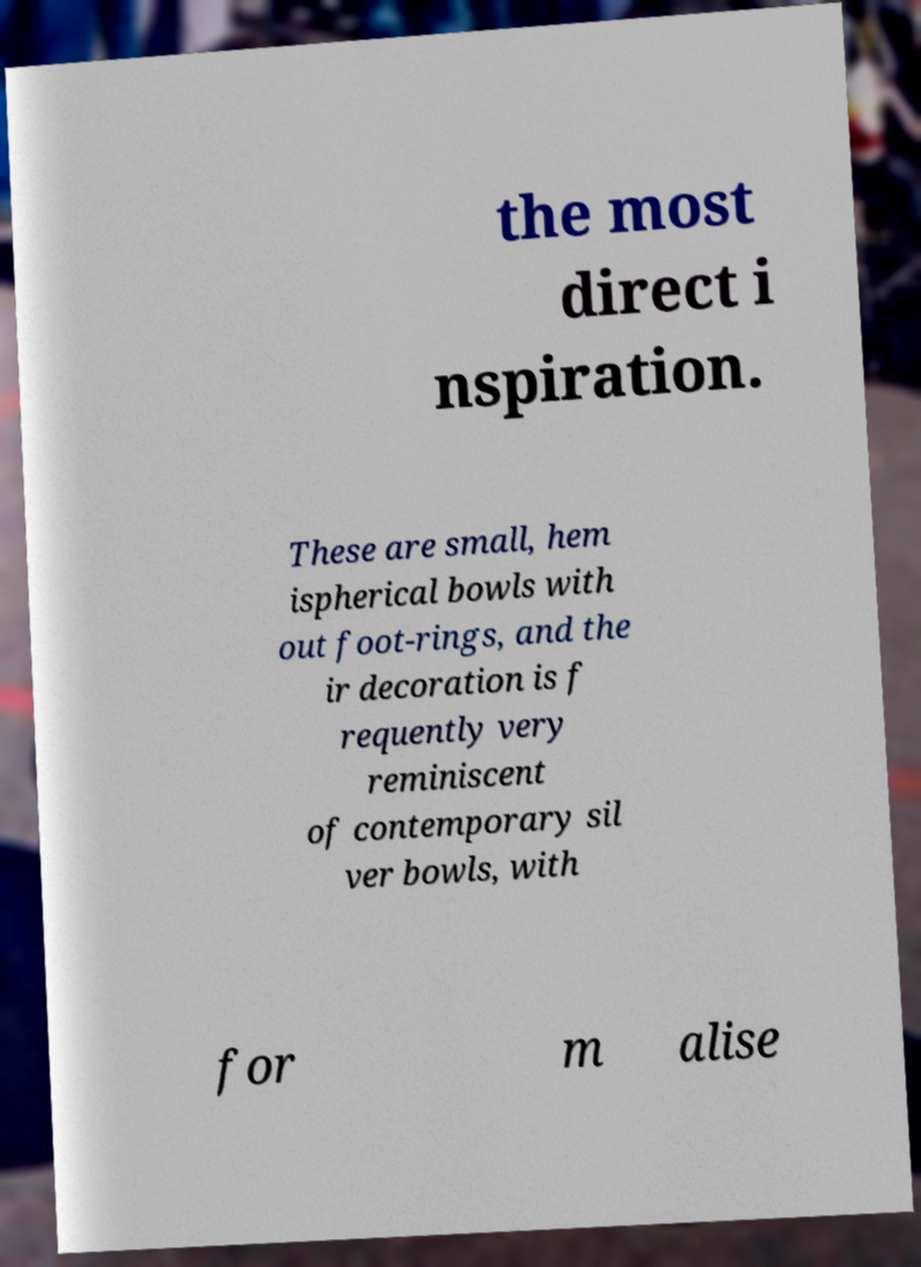Could you extract and type out the text from this image? the most direct i nspiration. These are small, hem ispherical bowls with out foot-rings, and the ir decoration is f requently very reminiscent of contemporary sil ver bowls, with for m alise 